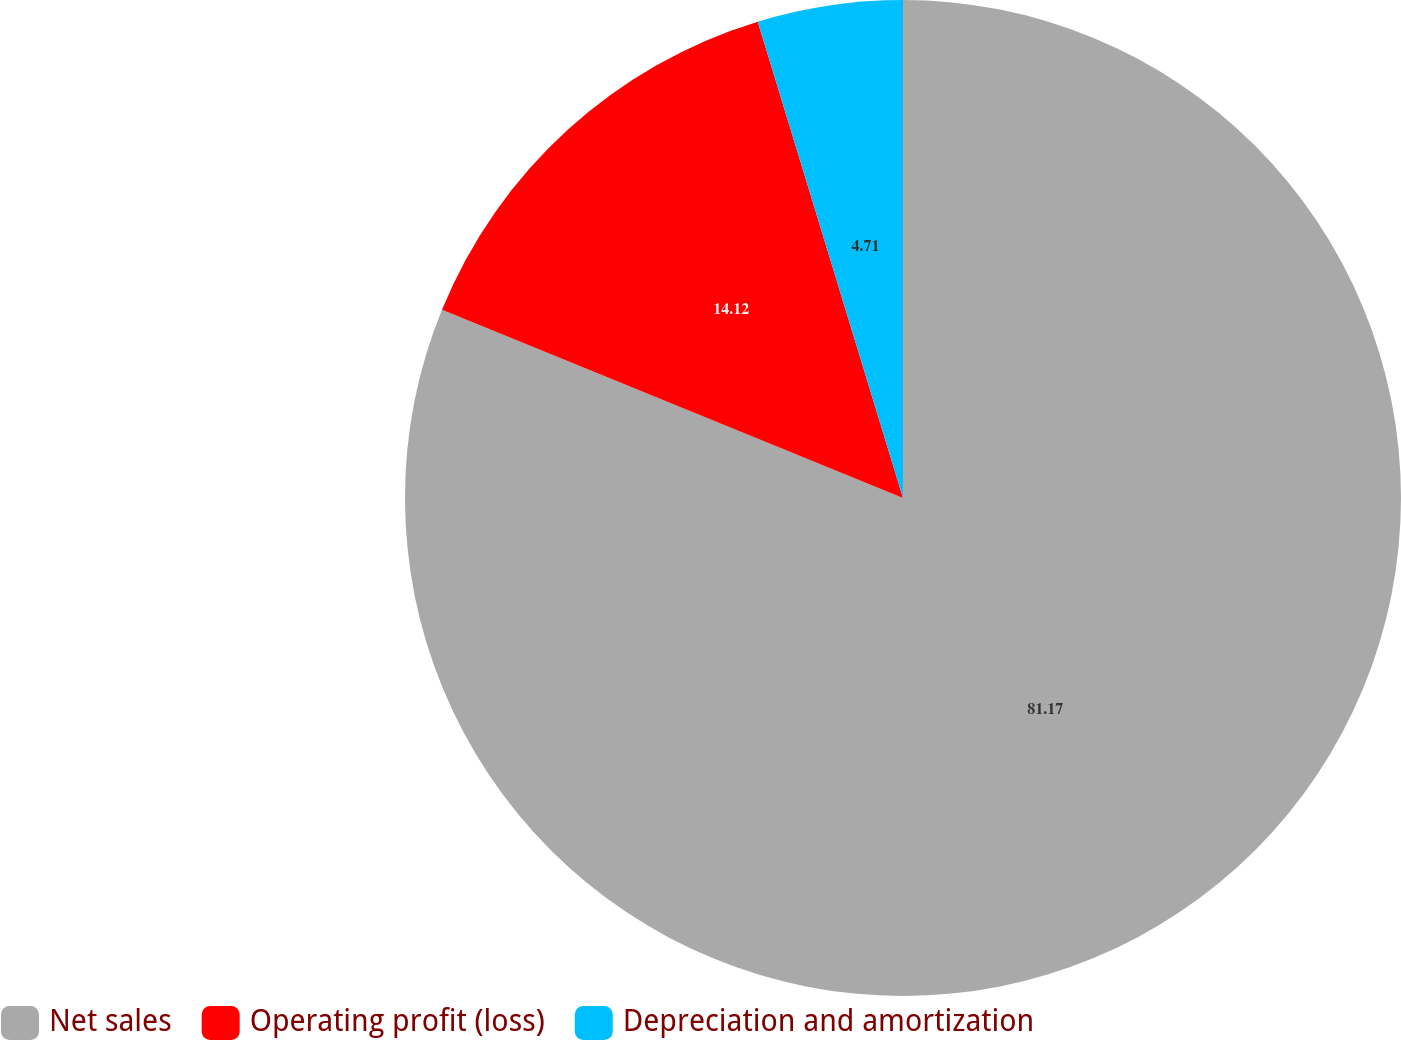<chart> <loc_0><loc_0><loc_500><loc_500><pie_chart><fcel>Net sales<fcel>Operating profit (loss)<fcel>Depreciation and amortization<nl><fcel>81.18%<fcel>14.12%<fcel>4.71%<nl></chart> 